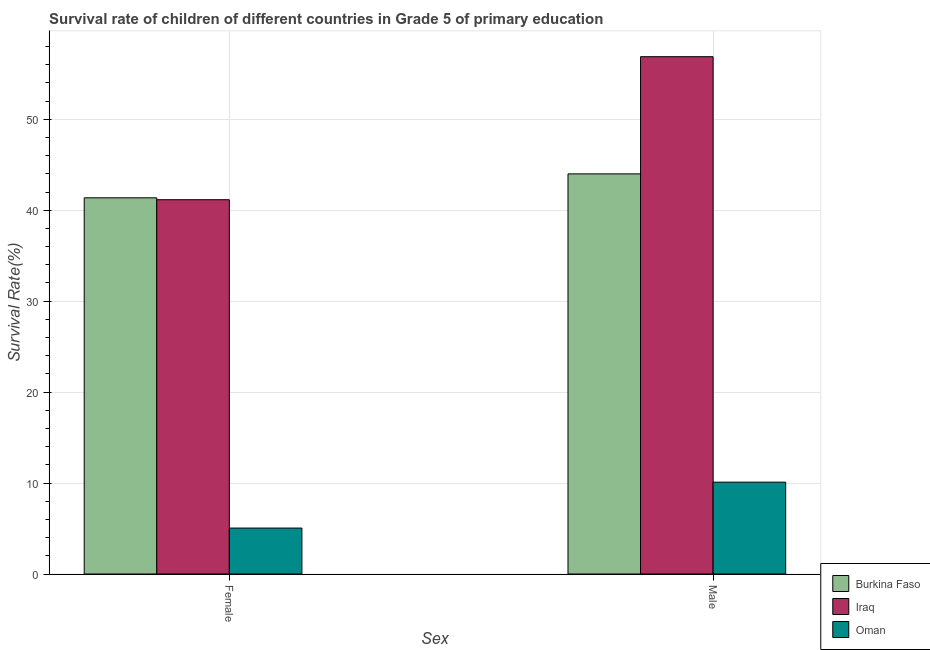How many bars are there on the 1st tick from the left?
Make the answer very short. 3. How many bars are there on the 2nd tick from the right?
Make the answer very short. 3. What is the survival rate of male students in primary education in Burkina Faso?
Give a very brief answer. 43.99. Across all countries, what is the maximum survival rate of male students in primary education?
Your response must be concise. 56.88. Across all countries, what is the minimum survival rate of male students in primary education?
Keep it short and to the point. 10.1. In which country was the survival rate of male students in primary education maximum?
Your answer should be very brief. Iraq. In which country was the survival rate of female students in primary education minimum?
Keep it short and to the point. Oman. What is the total survival rate of female students in primary education in the graph?
Keep it short and to the point. 87.56. What is the difference between the survival rate of male students in primary education in Oman and that in Burkina Faso?
Your answer should be very brief. -33.89. What is the difference between the survival rate of male students in primary education in Burkina Faso and the survival rate of female students in primary education in Oman?
Ensure brevity in your answer.  38.94. What is the average survival rate of male students in primary education per country?
Offer a very short reply. 36.99. What is the difference between the survival rate of female students in primary education and survival rate of male students in primary education in Oman?
Give a very brief answer. -5.05. What is the ratio of the survival rate of female students in primary education in Oman to that in Burkina Faso?
Provide a short and direct response. 0.12. Is the survival rate of male students in primary education in Burkina Faso less than that in Oman?
Make the answer very short. No. What does the 1st bar from the left in Male represents?
Offer a very short reply. Burkina Faso. What does the 3rd bar from the right in Female represents?
Make the answer very short. Burkina Faso. How many bars are there?
Your response must be concise. 6. Are all the bars in the graph horizontal?
Give a very brief answer. No. Does the graph contain grids?
Your answer should be very brief. Yes. Where does the legend appear in the graph?
Keep it short and to the point. Bottom right. How are the legend labels stacked?
Keep it short and to the point. Vertical. What is the title of the graph?
Your answer should be compact. Survival rate of children of different countries in Grade 5 of primary education. What is the label or title of the X-axis?
Your answer should be compact. Sex. What is the label or title of the Y-axis?
Make the answer very short. Survival Rate(%). What is the Survival Rate(%) in Burkina Faso in Female?
Ensure brevity in your answer.  41.36. What is the Survival Rate(%) in Iraq in Female?
Your answer should be very brief. 41.15. What is the Survival Rate(%) in Oman in Female?
Offer a very short reply. 5.05. What is the Survival Rate(%) in Burkina Faso in Male?
Keep it short and to the point. 43.99. What is the Survival Rate(%) of Iraq in Male?
Provide a succinct answer. 56.88. What is the Survival Rate(%) in Oman in Male?
Offer a very short reply. 10.1. Across all Sex, what is the maximum Survival Rate(%) in Burkina Faso?
Provide a succinct answer. 43.99. Across all Sex, what is the maximum Survival Rate(%) in Iraq?
Give a very brief answer. 56.88. Across all Sex, what is the maximum Survival Rate(%) of Oman?
Your response must be concise. 10.1. Across all Sex, what is the minimum Survival Rate(%) of Burkina Faso?
Offer a terse response. 41.36. Across all Sex, what is the minimum Survival Rate(%) in Iraq?
Provide a short and direct response. 41.15. Across all Sex, what is the minimum Survival Rate(%) in Oman?
Offer a terse response. 5.05. What is the total Survival Rate(%) in Burkina Faso in the graph?
Give a very brief answer. 85.35. What is the total Survival Rate(%) of Iraq in the graph?
Your answer should be compact. 98.03. What is the total Survival Rate(%) in Oman in the graph?
Offer a very short reply. 15.15. What is the difference between the Survival Rate(%) of Burkina Faso in Female and that in Male?
Offer a terse response. -2.63. What is the difference between the Survival Rate(%) of Iraq in Female and that in Male?
Offer a terse response. -15.72. What is the difference between the Survival Rate(%) of Oman in Female and that in Male?
Make the answer very short. -5.05. What is the difference between the Survival Rate(%) in Burkina Faso in Female and the Survival Rate(%) in Iraq in Male?
Provide a succinct answer. -15.52. What is the difference between the Survival Rate(%) in Burkina Faso in Female and the Survival Rate(%) in Oman in Male?
Your answer should be compact. 31.26. What is the difference between the Survival Rate(%) of Iraq in Female and the Survival Rate(%) of Oman in Male?
Provide a short and direct response. 31.05. What is the average Survival Rate(%) in Burkina Faso per Sex?
Provide a succinct answer. 42.68. What is the average Survival Rate(%) in Iraq per Sex?
Keep it short and to the point. 49.02. What is the average Survival Rate(%) in Oman per Sex?
Your answer should be very brief. 7.57. What is the difference between the Survival Rate(%) of Burkina Faso and Survival Rate(%) of Iraq in Female?
Your response must be concise. 0.21. What is the difference between the Survival Rate(%) of Burkina Faso and Survival Rate(%) of Oman in Female?
Your answer should be very brief. 36.31. What is the difference between the Survival Rate(%) of Iraq and Survival Rate(%) of Oman in Female?
Provide a short and direct response. 36.1. What is the difference between the Survival Rate(%) of Burkina Faso and Survival Rate(%) of Iraq in Male?
Provide a short and direct response. -12.88. What is the difference between the Survival Rate(%) of Burkina Faso and Survival Rate(%) of Oman in Male?
Your response must be concise. 33.89. What is the difference between the Survival Rate(%) in Iraq and Survival Rate(%) in Oman in Male?
Your answer should be very brief. 46.78. What is the ratio of the Survival Rate(%) in Burkina Faso in Female to that in Male?
Give a very brief answer. 0.94. What is the ratio of the Survival Rate(%) in Iraq in Female to that in Male?
Ensure brevity in your answer.  0.72. What is the ratio of the Survival Rate(%) in Oman in Female to that in Male?
Provide a succinct answer. 0.5. What is the difference between the highest and the second highest Survival Rate(%) of Burkina Faso?
Your answer should be very brief. 2.63. What is the difference between the highest and the second highest Survival Rate(%) of Iraq?
Keep it short and to the point. 15.72. What is the difference between the highest and the second highest Survival Rate(%) of Oman?
Provide a short and direct response. 5.05. What is the difference between the highest and the lowest Survival Rate(%) in Burkina Faso?
Keep it short and to the point. 2.63. What is the difference between the highest and the lowest Survival Rate(%) in Iraq?
Keep it short and to the point. 15.72. What is the difference between the highest and the lowest Survival Rate(%) in Oman?
Your answer should be very brief. 5.05. 